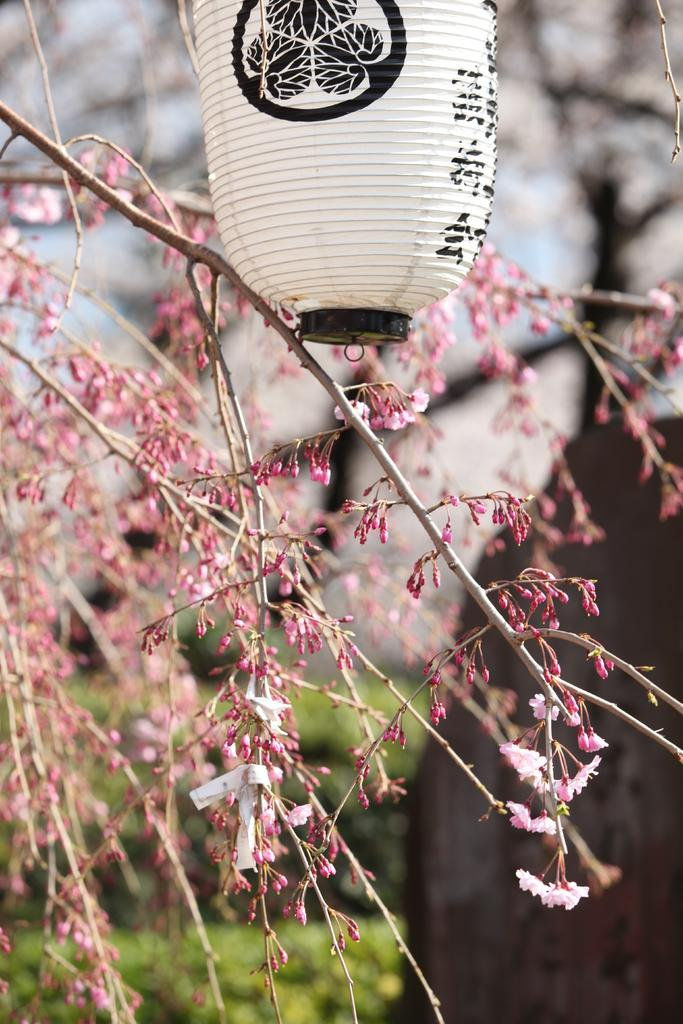What type of natural element is present in the image? There is a tree in the image. What else can be seen in the image besides the tree? There is an object in the image. How would you describe the appearance of the background in the image? The background of the image is blurred. What structures or elements can be seen in the background of the image? There is a house and plants in the background of the image. What type of animals can be seen performing at the show in the image? There is: There is no show or animals present in the image; it features a tree, an object, and a blurred background with a house and plants. 